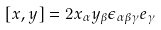<formula> <loc_0><loc_0><loc_500><loc_500>[ x , y ] = 2 x _ { \alpha } y _ { \beta } \epsilon _ { \alpha \beta \gamma } e _ { \gamma }</formula> 